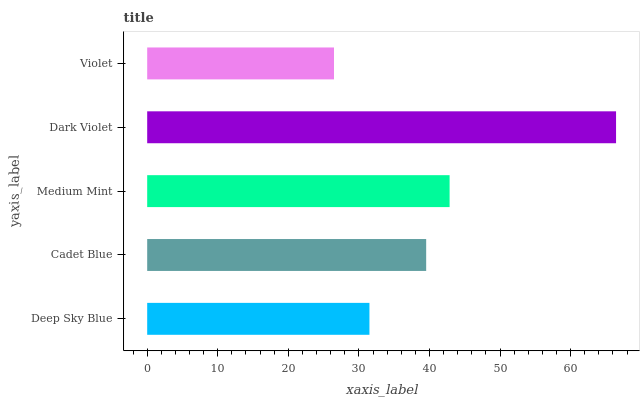Is Violet the minimum?
Answer yes or no. Yes. Is Dark Violet the maximum?
Answer yes or no. Yes. Is Cadet Blue the minimum?
Answer yes or no. No. Is Cadet Blue the maximum?
Answer yes or no. No. Is Cadet Blue greater than Deep Sky Blue?
Answer yes or no. Yes. Is Deep Sky Blue less than Cadet Blue?
Answer yes or no. Yes. Is Deep Sky Blue greater than Cadet Blue?
Answer yes or no. No. Is Cadet Blue less than Deep Sky Blue?
Answer yes or no. No. Is Cadet Blue the high median?
Answer yes or no. Yes. Is Cadet Blue the low median?
Answer yes or no. Yes. Is Violet the high median?
Answer yes or no. No. Is Medium Mint the low median?
Answer yes or no. No. 